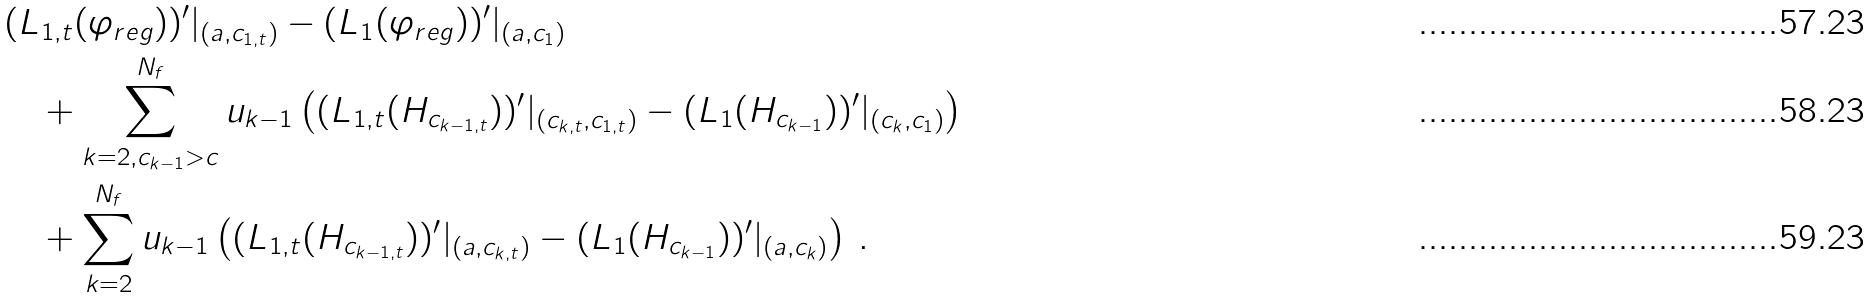Convert formula to latex. <formula><loc_0><loc_0><loc_500><loc_500>& ( \L L _ { 1 , t } ( \varphi _ { r e g } ) ) ^ { \prime } | _ { ( a , c _ { 1 , t } ) } - ( \L L _ { 1 } ( \varphi _ { r e g } ) ) ^ { \prime } | _ { ( a , c _ { 1 } ) } \\ & \quad + \sum _ { k = 2 , c _ { k - 1 } > c } ^ { N _ { f } } u _ { k - 1 } \left ( ( \L L _ { 1 , t } ( H _ { c _ { k - 1 , t } } ) ) ^ { \prime } | _ { ( c _ { k , t } , c _ { 1 , t } ) } - ( \L L _ { 1 } ( H _ { c _ { k - 1 } } ) ) ^ { \prime } | _ { ( c _ { k } , c _ { 1 } ) } \right ) \\ & \quad + \sum _ { k = 2 } ^ { N _ { f } } u _ { k - 1 } \left ( ( \L L _ { 1 , t } ( H _ { c _ { k - 1 , t } } ) ) ^ { \prime } | _ { ( a , c _ { k , t } ) } - ( \L L _ { 1 } ( H _ { c _ { k - 1 } } ) ) ^ { \prime } | _ { ( a , c _ { k } ) } \right ) \, .</formula> 